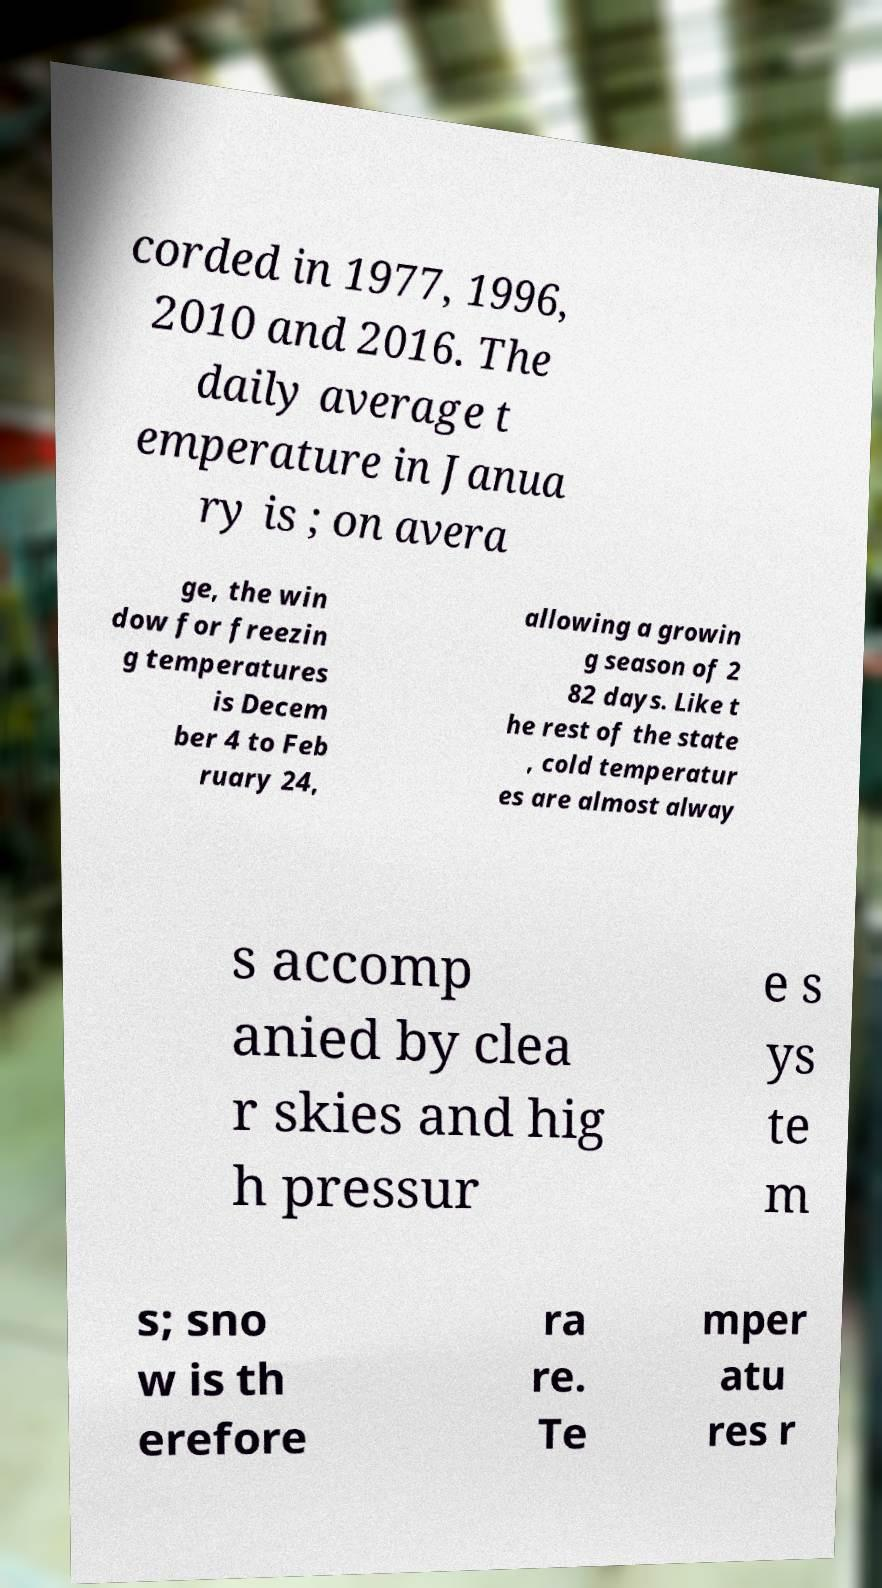For documentation purposes, I need the text within this image transcribed. Could you provide that? corded in 1977, 1996, 2010 and 2016. The daily average t emperature in Janua ry is ; on avera ge, the win dow for freezin g temperatures is Decem ber 4 to Feb ruary 24, allowing a growin g season of 2 82 days. Like t he rest of the state , cold temperatur es are almost alway s accomp anied by clea r skies and hig h pressur e s ys te m s; sno w is th erefore ra re. Te mper atu res r 